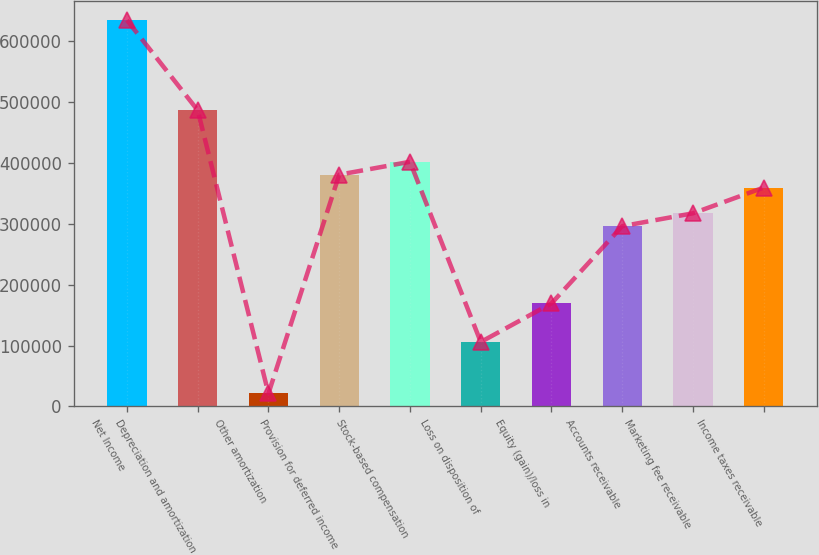Convert chart. <chart><loc_0><loc_0><loc_500><loc_500><bar_chart><fcel>Net Income<fcel>Depreciation and amortization<fcel>Other amortization<fcel>Provision for deferred income<fcel>Stock-based compensation<fcel>Loss on disposition of<fcel>Equity (gain)/loss in<fcel>Accounts receivable<fcel>Marketing fee receivable<fcel>Income taxes receivable<nl><fcel>634555<fcel>486497<fcel>21170.2<fcel>380741<fcel>401892<fcel>105775<fcel>169229<fcel>296136<fcel>317287<fcel>359589<nl></chart> 